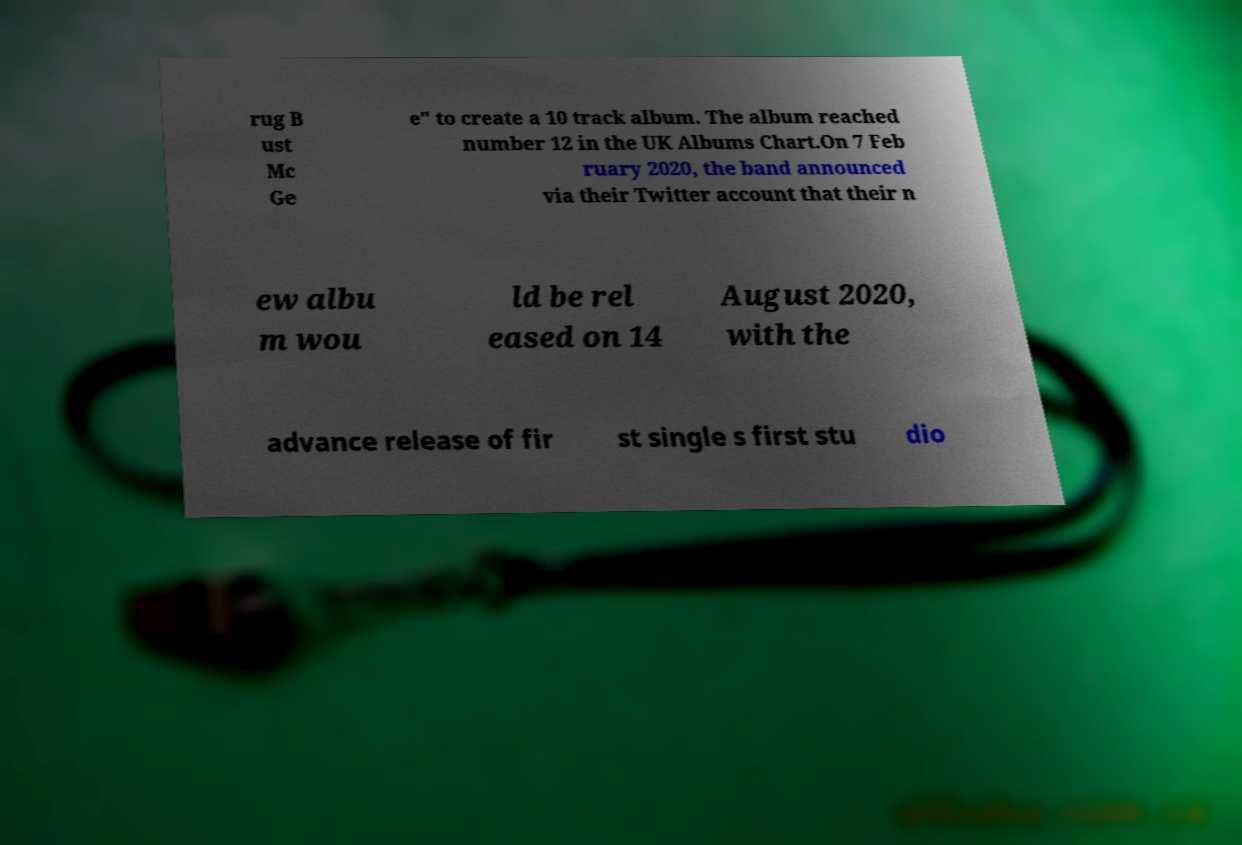Can you read and provide the text displayed in the image?This photo seems to have some interesting text. Can you extract and type it out for me? rug B ust Mc Ge e" to create a 10 track album. The album reached number 12 in the UK Albums Chart.On 7 Feb ruary 2020, the band announced via their Twitter account that their n ew albu m wou ld be rel eased on 14 August 2020, with the advance release of fir st single s first stu dio 